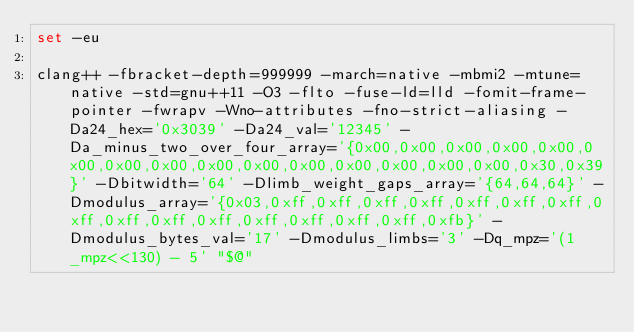<code> <loc_0><loc_0><loc_500><loc_500><_Bash_>set -eu

clang++ -fbracket-depth=999999 -march=native -mbmi2 -mtune=native -std=gnu++11 -O3 -flto -fuse-ld=lld -fomit-frame-pointer -fwrapv -Wno-attributes -fno-strict-aliasing -Da24_hex='0x3039' -Da24_val='12345' -Da_minus_two_over_four_array='{0x00,0x00,0x00,0x00,0x00,0x00,0x00,0x00,0x00,0x00,0x00,0x00,0x00,0x00,0x00,0x30,0x39}' -Dbitwidth='64' -Dlimb_weight_gaps_array='{64,64,64}' -Dmodulus_array='{0x03,0xff,0xff,0xff,0xff,0xff,0xff,0xff,0xff,0xff,0xff,0xff,0xff,0xff,0xff,0xff,0xfb}' -Dmodulus_bytes_val='17' -Dmodulus_limbs='3' -Dq_mpz='(1_mpz<<130) - 5' "$@"
</code> 